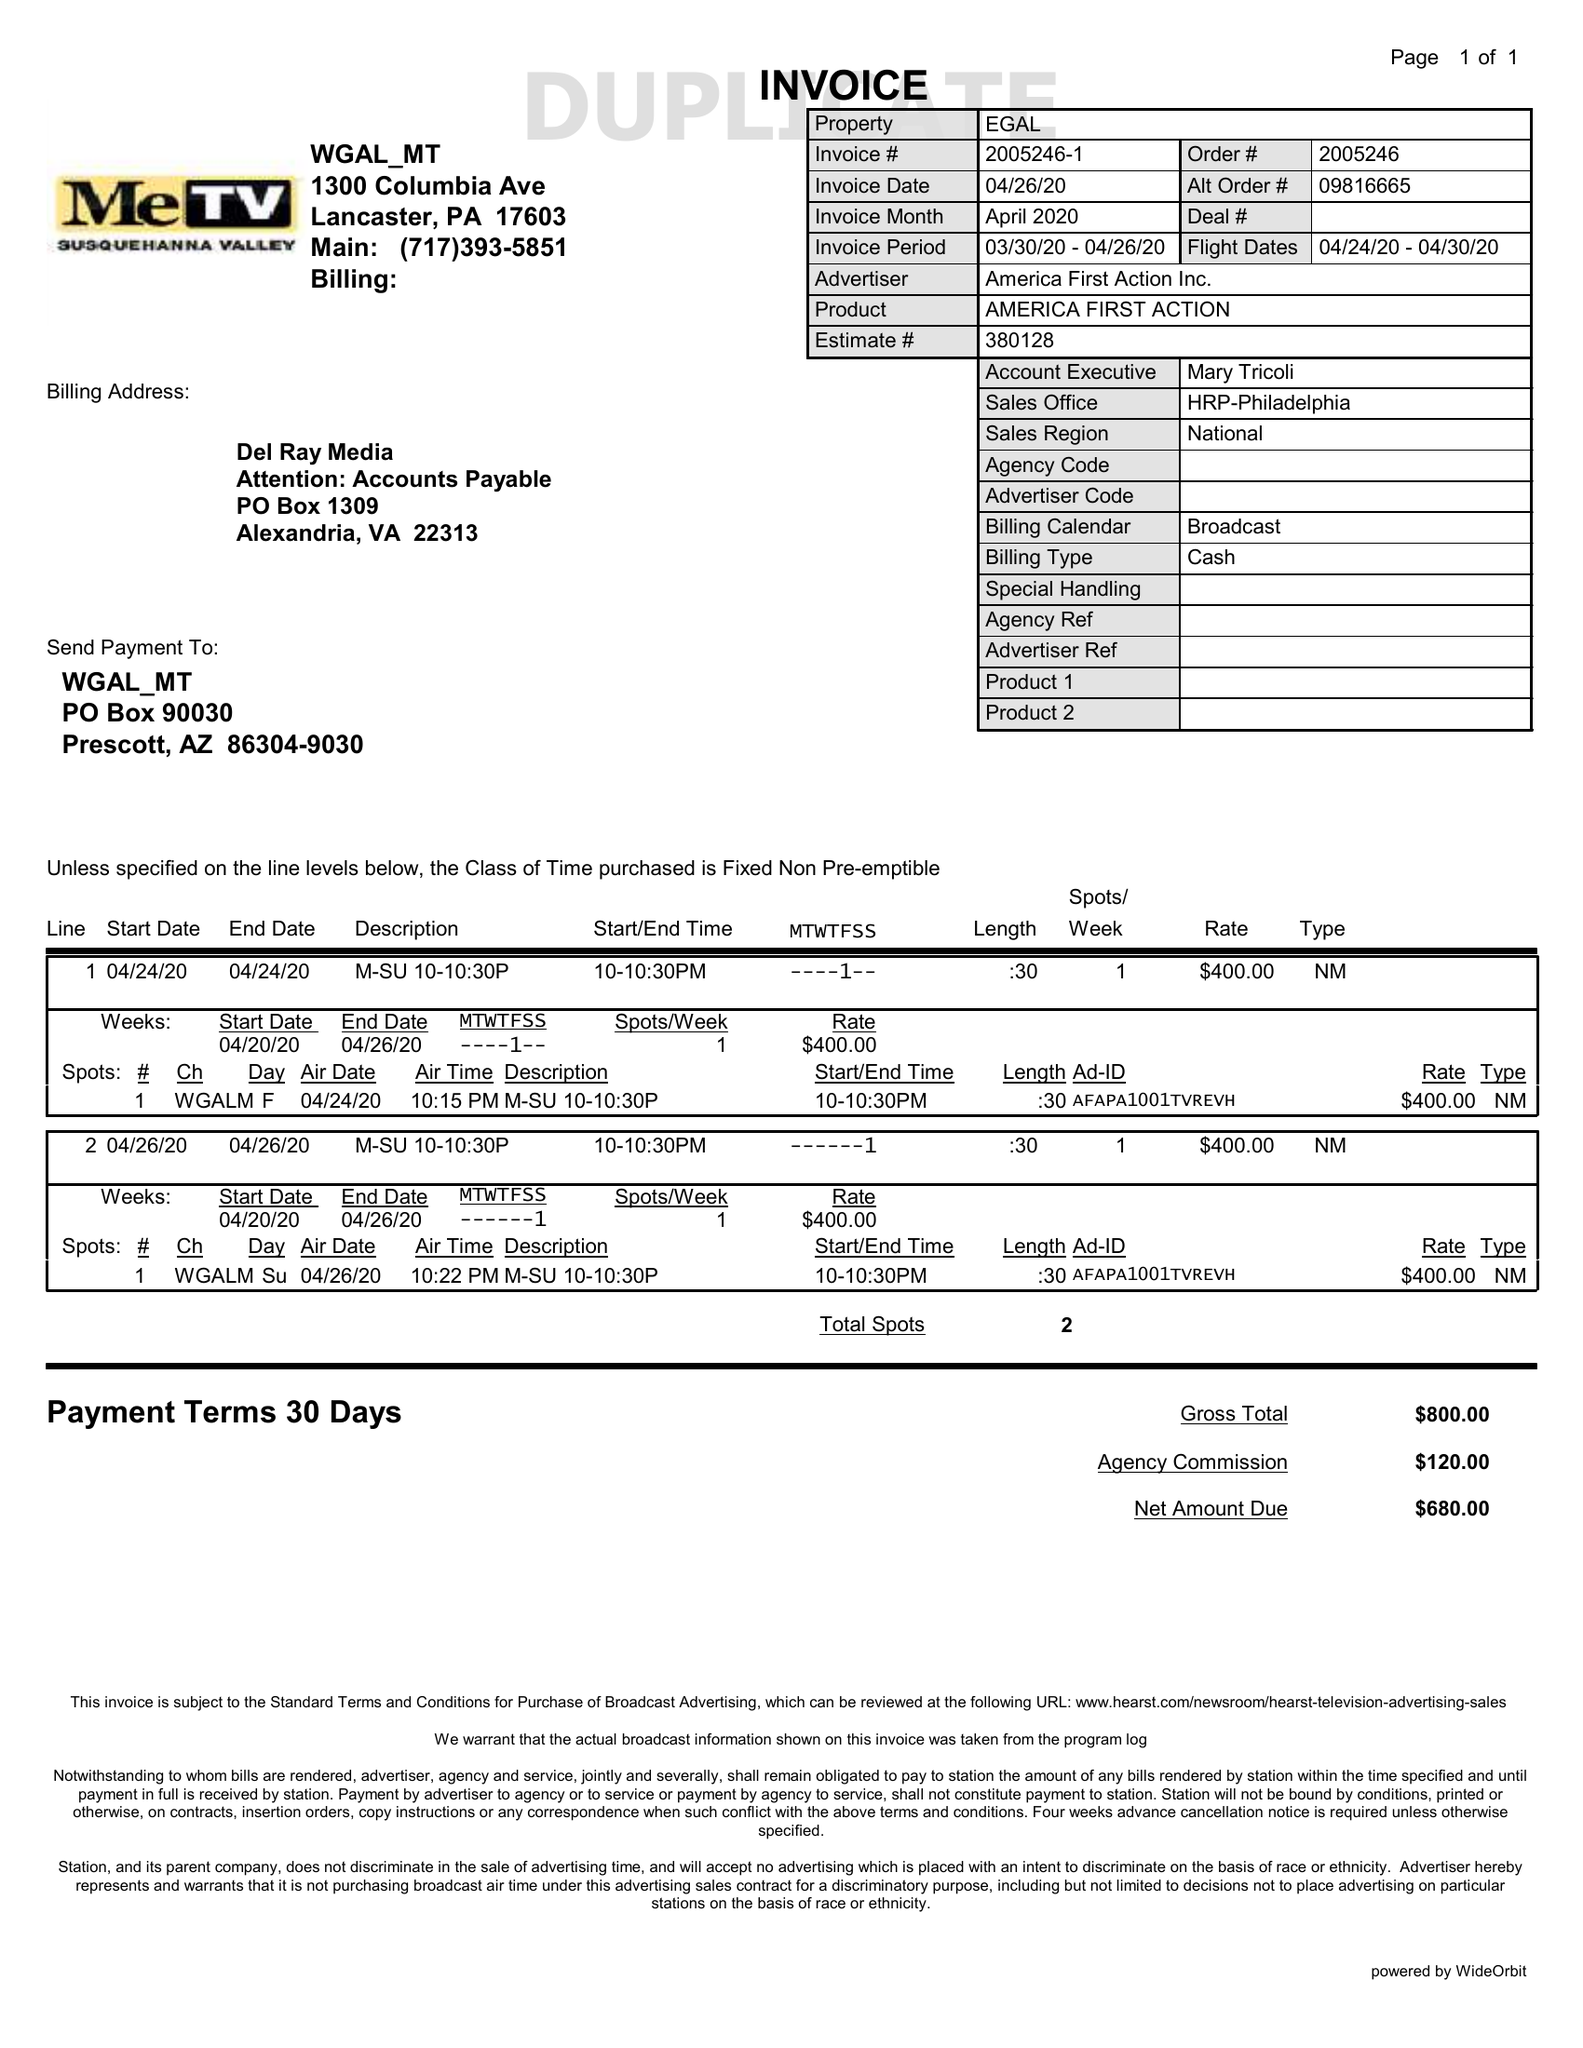What is the value for the flight_to?
Answer the question using a single word or phrase. 04/30/20 